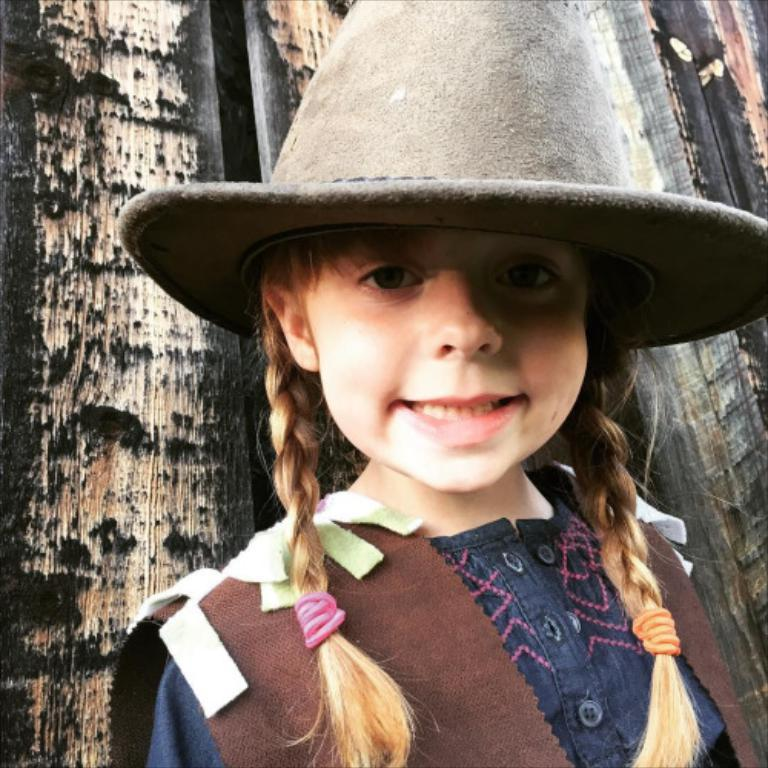Who is the main subject in the image? There is a girl in the image. What is the girl wearing on her head? The girl is wearing a hat. What type of material can be seen in the background of the image? There is a wooden wall in the background of the image. What type of wool is the girl using to knit a sweater in the image? There is no wool or knitting activity present in the image. How many cats can be seen playing with the girl in the image? There are no cats present in the image. 